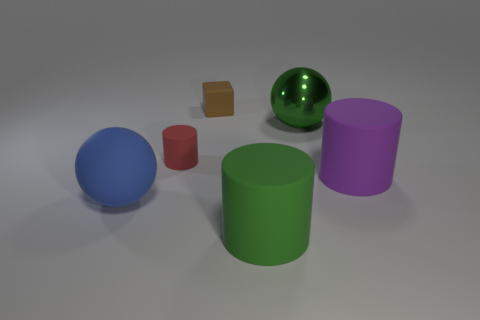How many objects are large balls that are right of the tiny red object or purple rubber cylinders?
Provide a succinct answer. 2. Is the size of the blue ball in front of the tiny red rubber object the same as the green metal thing that is in front of the cube?
Provide a short and direct response. Yes. Are there any other things that have the same material as the blue ball?
Offer a very short reply. Yes. How many things are either rubber things that are in front of the tiny cube or large cylinders behind the big green rubber cylinder?
Make the answer very short. 4. Does the large green ball have the same material as the cylinder that is behind the large purple thing?
Your answer should be compact. No. What shape is the big object that is behind the large blue thing and in front of the big green metallic thing?
Ensure brevity in your answer.  Cylinder. What number of other objects are the same color as the metallic thing?
Provide a short and direct response. 1. The big green metallic thing is what shape?
Your response must be concise. Sphere. What is the color of the big object in front of the big object that is left of the tiny brown thing?
Give a very brief answer. Green. There is a small rubber cylinder; is its color the same as the big object to the left of the brown rubber block?
Provide a short and direct response. No. 